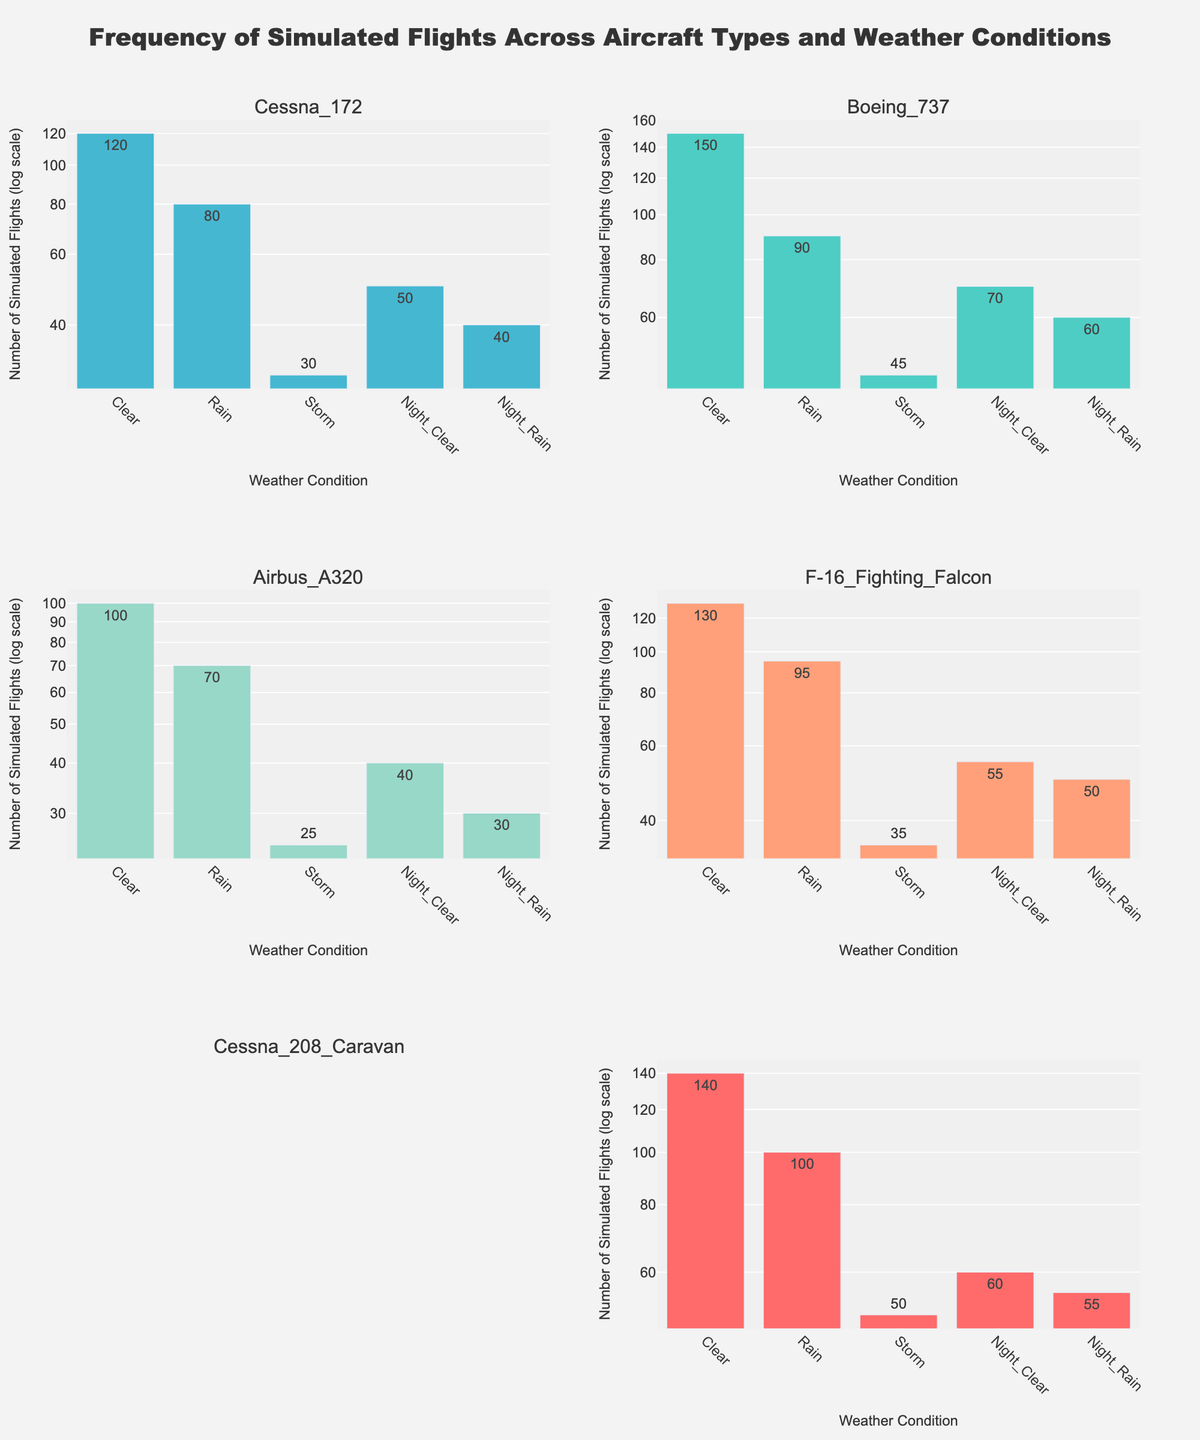Which aircraft type shows the highest number of simulated flights in clear weather? The y-axis indicates the number of simulated flights, and each bar represents a different weather condition for each aircraft type. Look at the tallest bar labeled 'Clear'.
Answer: Cessna 172 Which weather condition has the fewest simulated flights for the F-16 Fighting Falcon? Observe the bars for the F-16 Fighting Falcon and identify the shortest bar. The x-axis labels indicate the weather conditions.
Answer: Storm How many more simulated flights does the Cessna 208 Caravan have in rain compared to the Boeing 737 in clear weather? First, find the number of simulated flights for the Cessna 208 Caravan in rain (100) and compare it to the Boeing 737 in clear weather (120). Calculate the difference.
Answer: 20 What is the total number of simulated flights across all weather conditions for the Airbus A320? Add the number of simulated flights for each weather condition for the Airbus A320 (130 + 95 + 35 + 55 + 50).
Answer: 365 Which aircraft type has the closest number of simulated flights in clear weather compared to the Cessna 208 Caravan? Compare the number of simulated flights in clear weather for each aircraft type and find the one closest to the Cessna 208 Caravan (140).
Answer: Cessna 172 What is the ratio of simulated flights in night clear weather for the Airbus A320 to the F-16 Fighting Falcon? Divide the number of night clear simulated flights for the Airbus A320 (55) by the number for the F-16 Fighting Falcon (40).
Answer: 1.375 Which aircraft type has the most varied number of simulated flights across different weather conditions? Look for the aircraft type with the biggest difference between the highest and lowest number of simulated flights based on the height of the bars.
Answer: Cessna 208 Caravan How does the number of simulated flights in stormy weather for the Boeing 737 compare to that for the Cessna 172? Compare the heights of the storm bars for the Boeing 737 and the Cessna 172. The Boeing 737 has 30 in storm, and the Cessna 172 has 45. Find the difference.
Answer: Boeing 737 has 15 fewer simulated flights 